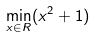<formula> <loc_0><loc_0><loc_500><loc_500>\min _ { x \in R } ( x ^ { 2 } + 1 )</formula> 